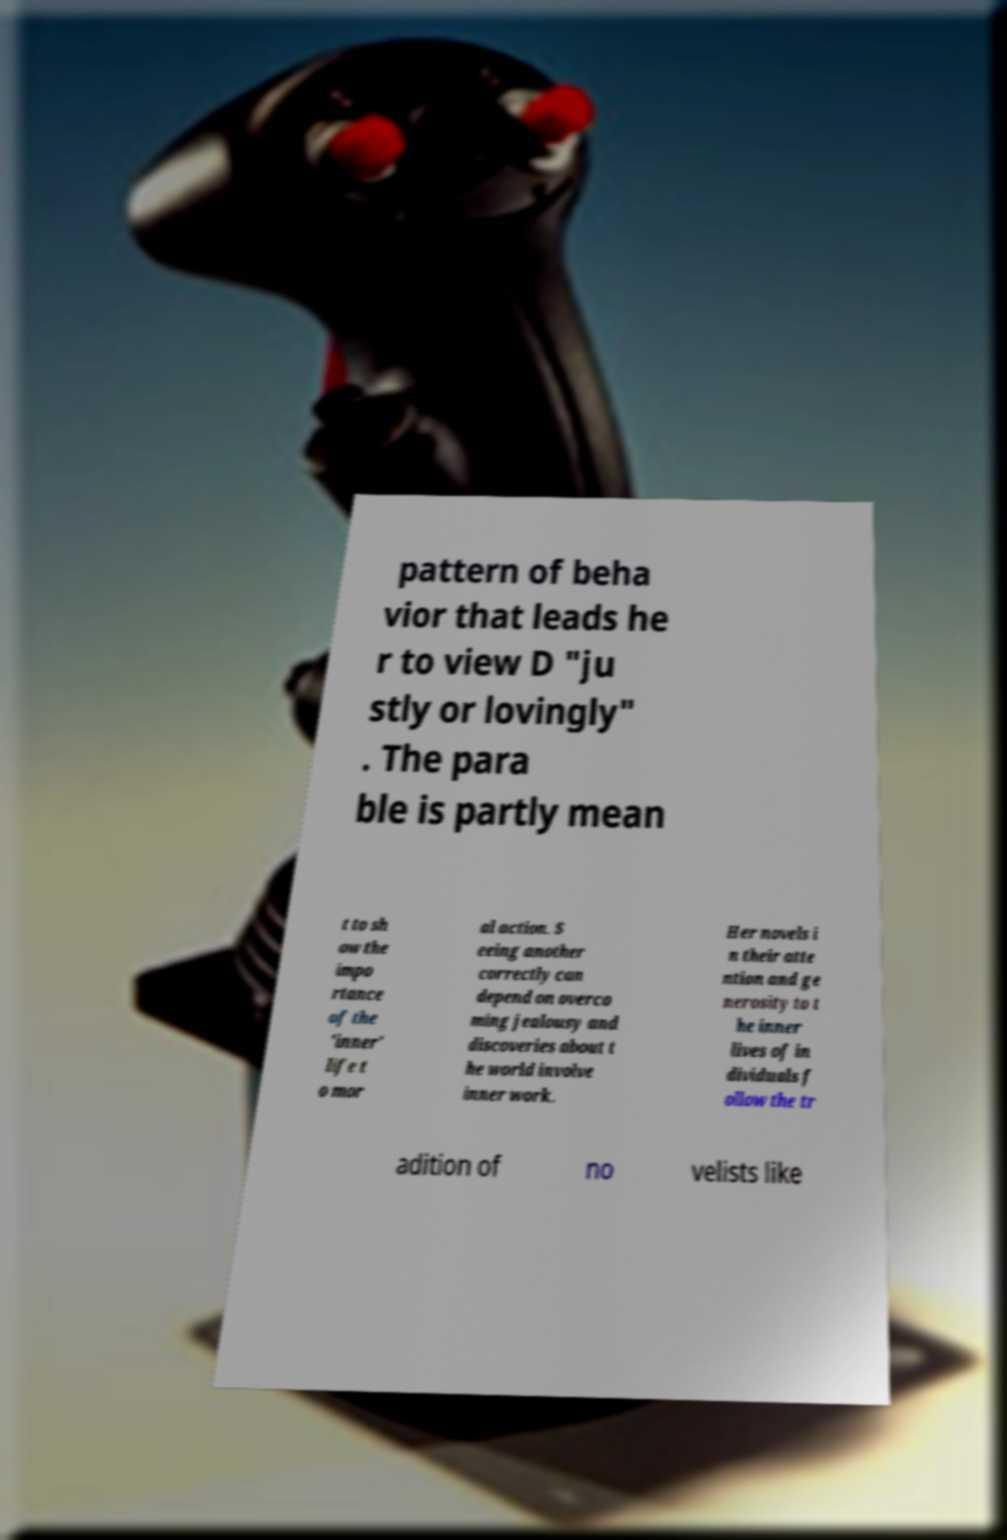Please identify and transcribe the text found in this image. pattern of beha vior that leads he r to view D "ju stly or lovingly" . The para ble is partly mean t to sh ow the impo rtance of the 'inner' life t o mor al action. S eeing another correctly can depend on overco ming jealousy and discoveries about t he world involve inner work. Her novels i n their atte ntion and ge nerosity to t he inner lives of in dividuals f ollow the tr adition of no velists like 